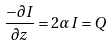Convert formula to latex. <formula><loc_0><loc_0><loc_500><loc_500>\frac { - \partial I } { \partial z } = 2 \alpha I = Q</formula> 